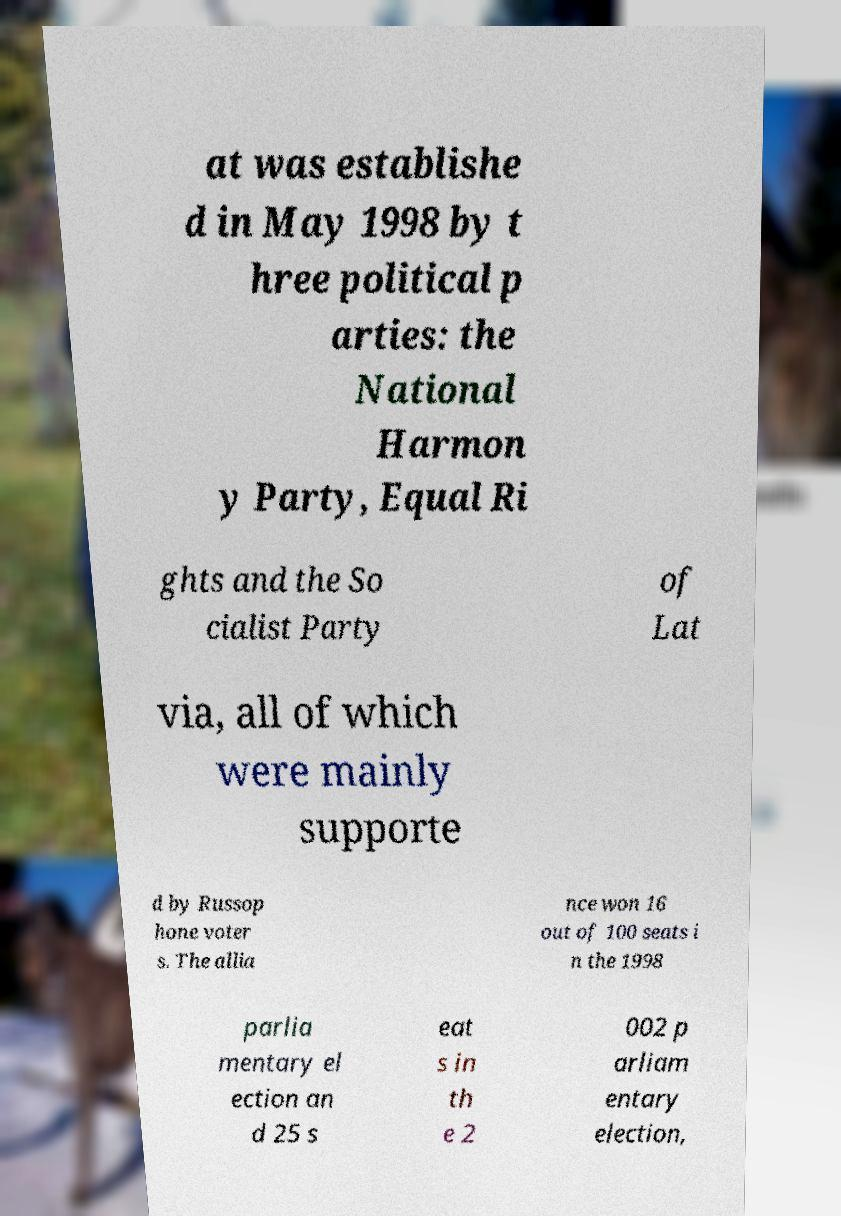Could you extract and type out the text from this image? at was establishe d in May 1998 by t hree political p arties: the National Harmon y Party, Equal Ri ghts and the So cialist Party of Lat via, all of which were mainly supporte d by Russop hone voter s. The allia nce won 16 out of 100 seats i n the 1998 parlia mentary el ection an d 25 s eat s in th e 2 002 p arliam entary election, 